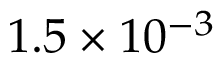<formula> <loc_0><loc_0><loc_500><loc_500>1 . 5 \times 1 0 ^ { - 3 }</formula> 